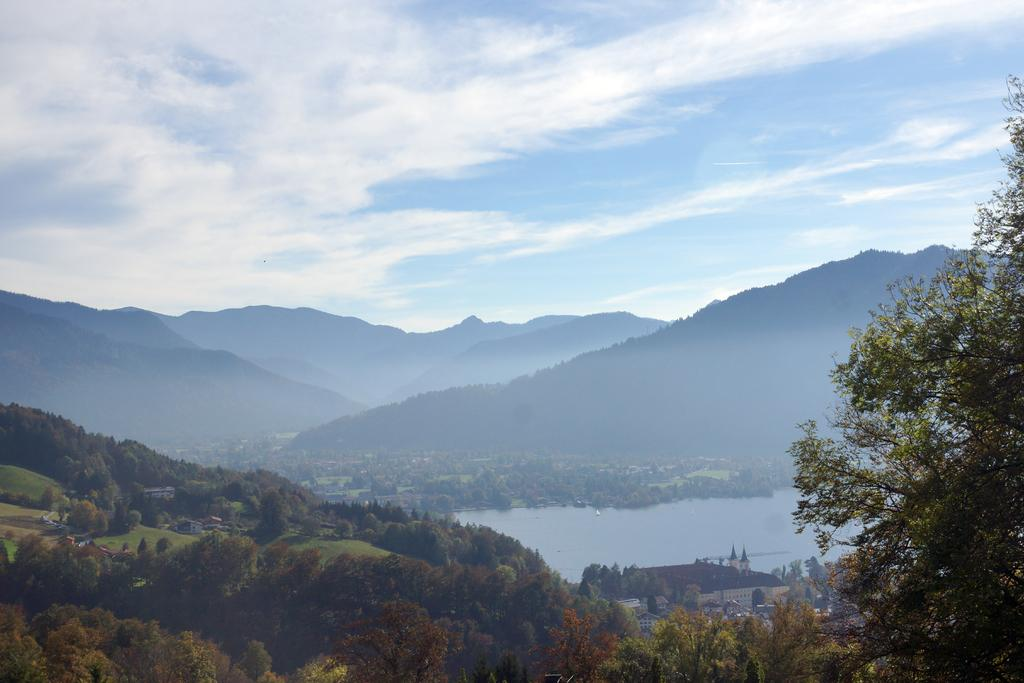What type of natural elements can be seen in the image? There are trees and hills visible in the image. What type of man-made structures are present in the image? There are houses in the image. What is the water feature in the image? There is water visible in the image. What can be seen in the background of the image? The sky is visible in the background of the image. Where are the ants crawling on the trees in the image? There are no ants present in the image; it only features trees, houses, water, hills, and the sky. What type of vase can be seen on the hill in the image? There is no vase present on the hill or anywhere else in the image. 